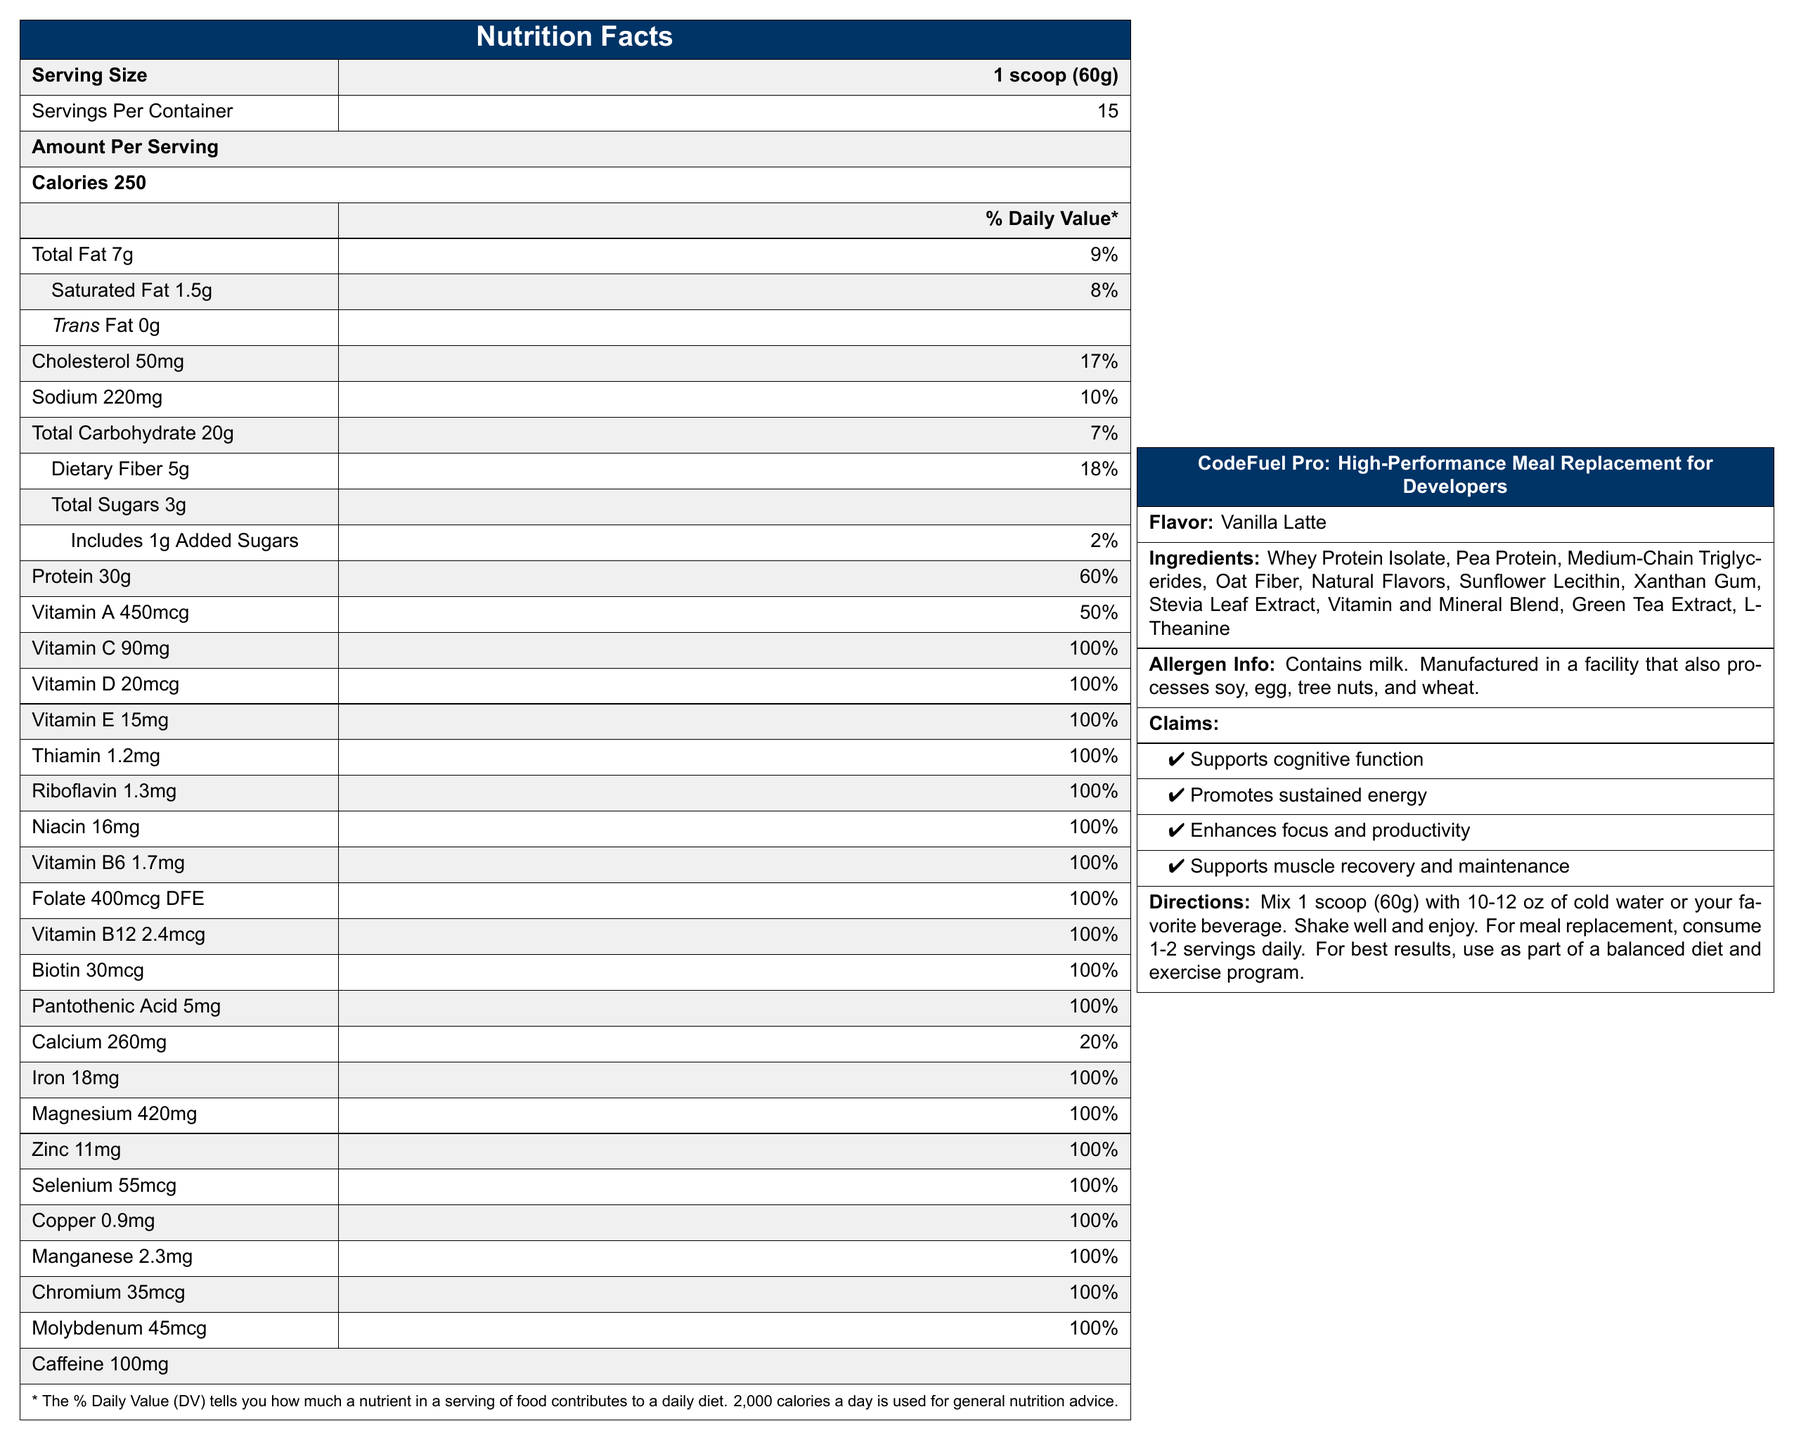what is the serving size? The serving size is clearly listed as "1 scoop (60g)" in the document.
Answer: 1 scoop (60g) how many servings are there per container? The document states that there are 15 servings per container.
Answer: 15 how many calories are there per serving? The number of calories per serving is specified as 250.
Answer: 250 what is the amount of protein per serving? The protein content per serving is listed as 30g.
Answer: 30g list three vitamins included and their daily values. The document lists the daily values for Vitamin A (50%), Vitamin C (100%), and Vitamin D (100%).
Answer: Vitamin A: 50%, Vitamin C: 100%, Vitamin D: 100% which nutrient has the highest daily value percentage? A. Vitamin A B. Vitamin C C. Magnesium D. Protein Vitamin C has a daily value percentage of 100%, which is the highest among the options.
Answer: B. Vitamin C how much caffeine is in one serving? The amount of caffeine per serving is listed as 100mg.
Answer: 100mg are there any allergens present in this product? The allergen information states that the product contains milk and is manufactured in a facility that processes soy, egg, tree nuts, and wheat.
Answer: Yes what flavor is the product? The document specifies that the flavor is Vanilla Latte.
Answer: Vanilla Latte what is the main ingredient in this product? A. Oat Fiber B. Pea Protein C. Whey Protein Isolate D. Sunflower Lecithin Whey Protein Isolate is listed first in the ingredients, indicating it is the main ingredient.
Answer: C. Whey Protein Isolate does this product contain any added sugars? The document specifies that the product includes 1g of added sugars.
Answer: Yes describe the primary purpose and claims of this product. The product description and claims in the document state that CodeFuel Pro aims to support developers' cognitive function, energy levels, focus, productivity, muscle recovery, and maintenance.
Answer: CodeFuel Pro is a high-performance meal replacement shake designed for developers. It supports cognitive function, promotes sustained energy, enhances focus and productivity, and supports muscle recovery and maintenance. how much fat is in each serving? The total fat content per serving is listed as 7g.
Answer: 7g how many carbohydrates does each serving contain? The total carbohydrate content per serving is specified as 20g.
Answer: 20g how much dietary fiber is in each serving? The document lists the dietary fiber content as 5g per serving.
Answer: 5g what are the directions for consuming this product? The directions state to mix 1 scoop with 10-12 oz of cold water or a favorite beverage and to consume 1-2 servings daily for meal replacement.
Answer: Mix 1 scoop (60g) with 10-12 oz of cold water or your favorite beverage. Shake well and enjoy. For meal replacement, consume 1-2 servings daily. Use as part of a balanced diet and exercise program. is this product free of gluten? The document does not provide specific information on whether the product is gluten-free; it only mentions that it is manufactured in a facility that processes wheat.
Answer: Cannot be determined how many mg of sodium are in one serving? The sodium content per serving is listed as 220mg.
Answer: 220 mg why might a developer consider using this product? The product's claims include supporting cognitive function, promoting sustained energy, enhancing focus and productivity, and aiding in muscle recovery and maintenance, which might appeal to developers working long hours.
Answer: To support cognitive function, sustained energy, focus, productivity, muscle recovery, and maintenance. 